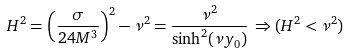<formula> <loc_0><loc_0><loc_500><loc_500>H ^ { 2 } = \left ( \frac { \sigma } { 2 4 M ^ { 3 } } \right ) ^ { 2 } - \nu ^ { 2 } = \frac { \nu ^ { 2 } } { \sinh ^ { 2 } ( \nu y _ { 0 } ) } \, \Rightarrow ( H ^ { 2 } < \nu ^ { 2 } )</formula> 